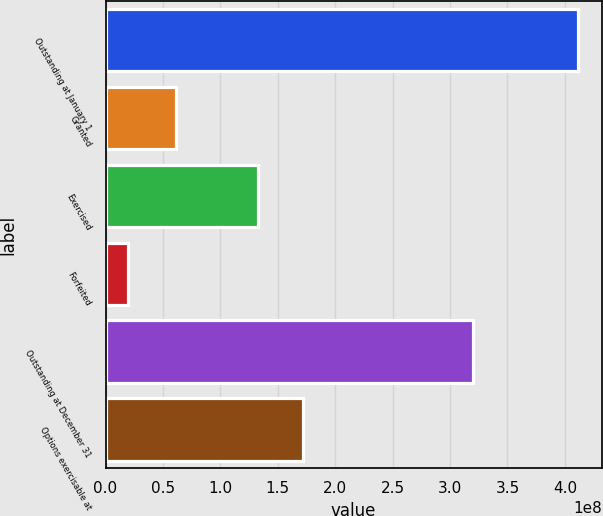Convert chart to OTSL. <chart><loc_0><loc_0><loc_500><loc_500><bar_chart><fcel>Outstanding at January 1<fcel>Granted<fcel>Exercised<fcel>Forfeited<fcel>Outstanding at December 31<fcel>Options exercisable at<nl><fcel>4.11447e+08<fcel>6.13368e+07<fcel>1.32492e+08<fcel>1.99609e+07<fcel>3.20331e+08<fcel>1.7164e+08<nl></chart> 